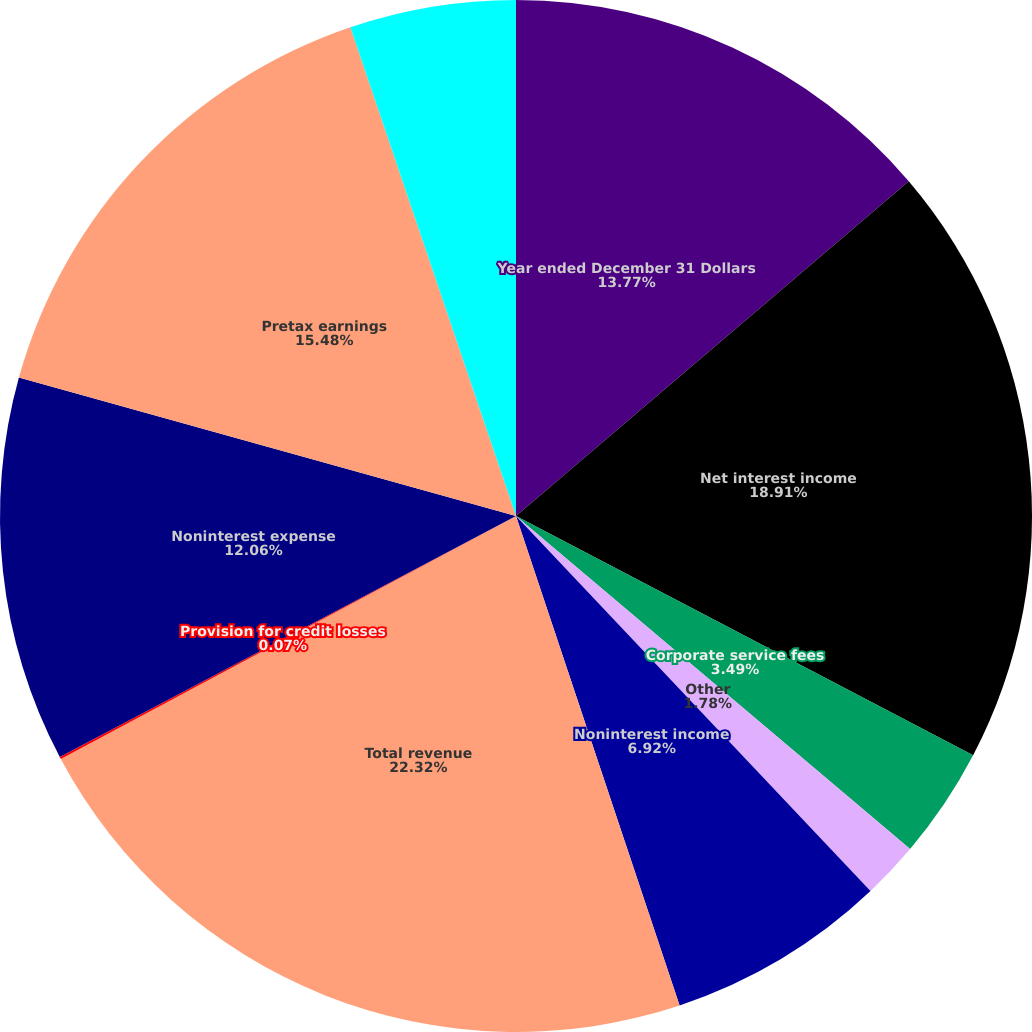Convert chart. <chart><loc_0><loc_0><loc_500><loc_500><pie_chart><fcel>Year ended December 31 Dollars<fcel>Net interest income<fcel>Corporate service fees<fcel>Other<fcel>Noninterest income<fcel>Total revenue<fcel>Provision for credit losses<fcel>Noninterest expense<fcel>Pretax earnings<fcel>Income taxes<nl><fcel>13.77%<fcel>18.91%<fcel>3.49%<fcel>1.78%<fcel>6.92%<fcel>22.33%<fcel>0.07%<fcel>12.06%<fcel>15.48%<fcel>5.2%<nl></chart> 